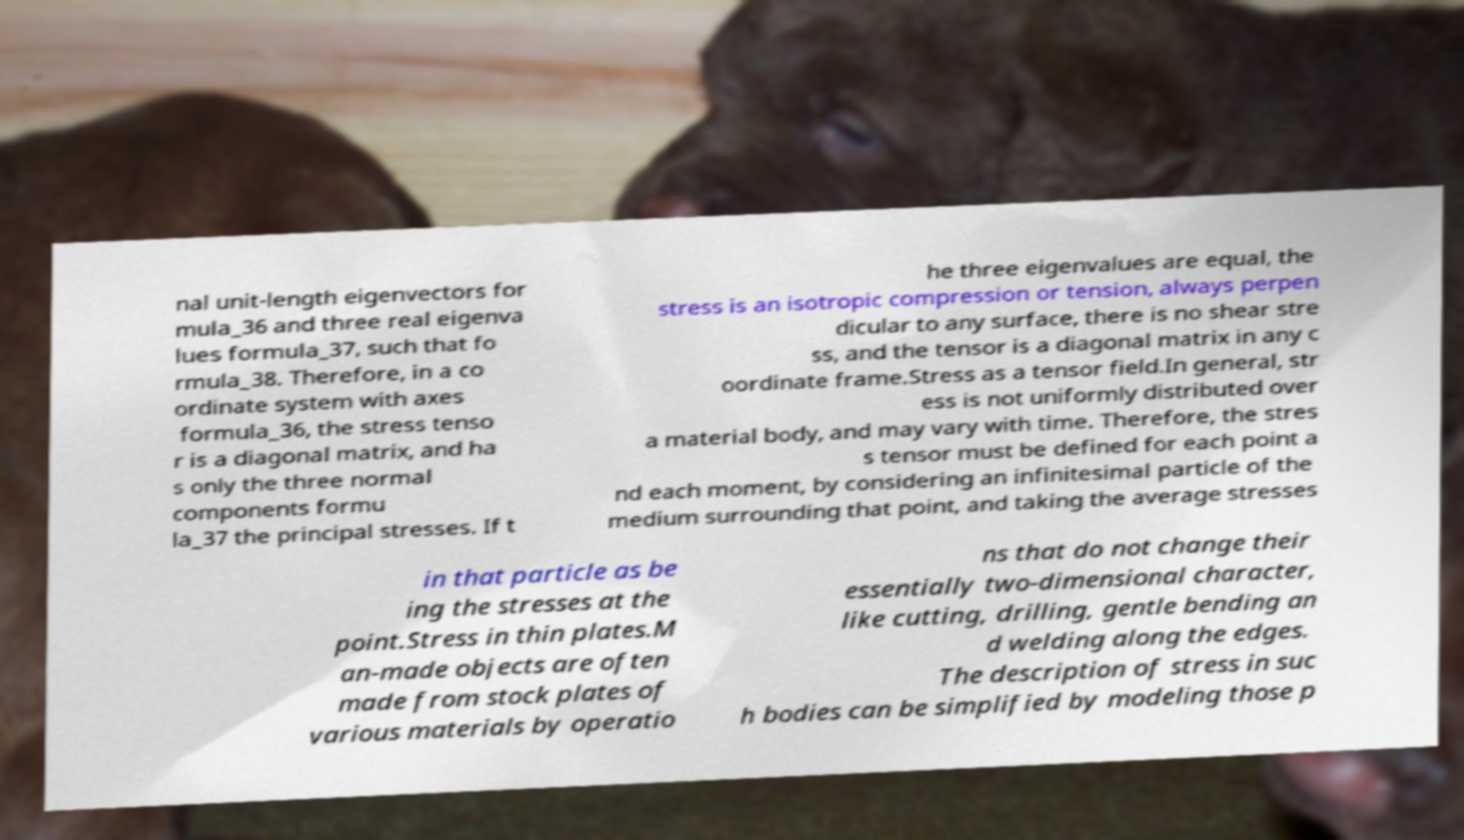Could you extract and type out the text from this image? nal unit-length eigenvectors for mula_36 and three real eigenva lues formula_37, such that fo rmula_38. Therefore, in a co ordinate system with axes formula_36, the stress tenso r is a diagonal matrix, and ha s only the three normal components formu la_37 the principal stresses. If t he three eigenvalues are equal, the stress is an isotropic compression or tension, always perpen dicular to any surface, there is no shear stre ss, and the tensor is a diagonal matrix in any c oordinate frame.Stress as a tensor field.In general, str ess is not uniformly distributed over a material body, and may vary with time. Therefore, the stres s tensor must be defined for each point a nd each moment, by considering an infinitesimal particle of the medium surrounding that point, and taking the average stresses in that particle as be ing the stresses at the point.Stress in thin plates.M an-made objects are often made from stock plates of various materials by operatio ns that do not change their essentially two-dimensional character, like cutting, drilling, gentle bending an d welding along the edges. The description of stress in suc h bodies can be simplified by modeling those p 